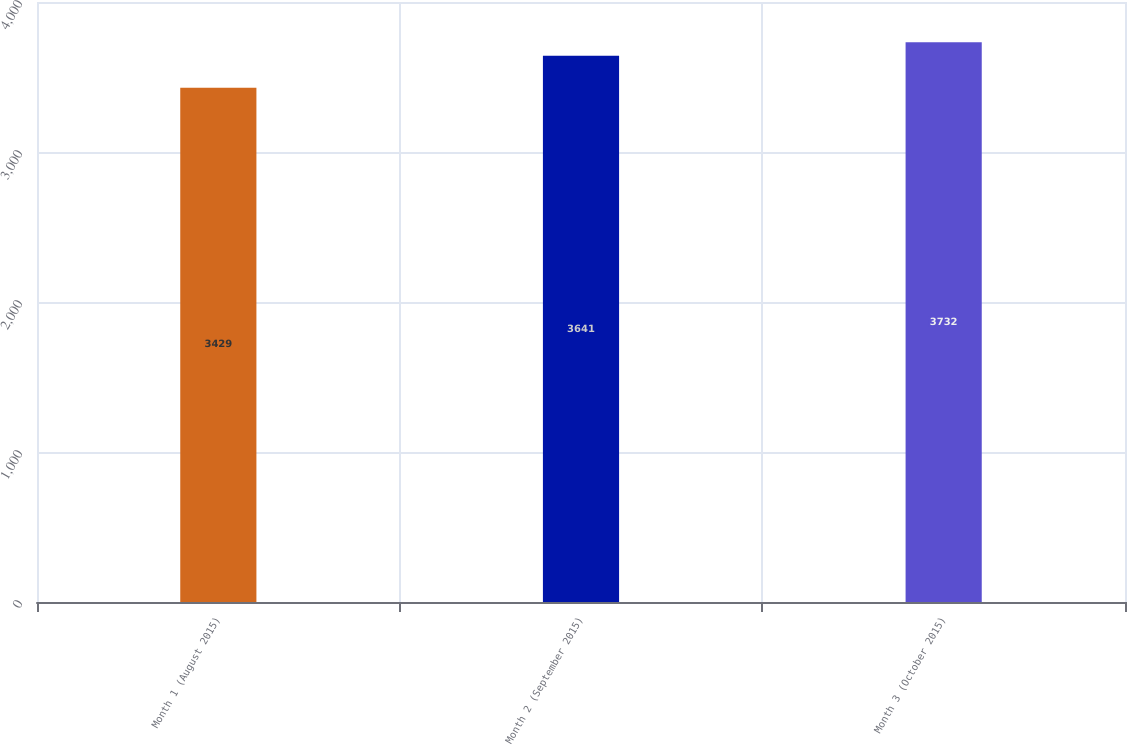Convert chart. <chart><loc_0><loc_0><loc_500><loc_500><bar_chart><fcel>Month 1 (August 2015)<fcel>Month 2 (September 2015)<fcel>Month 3 (October 2015)<nl><fcel>3429<fcel>3641<fcel>3732<nl></chart> 